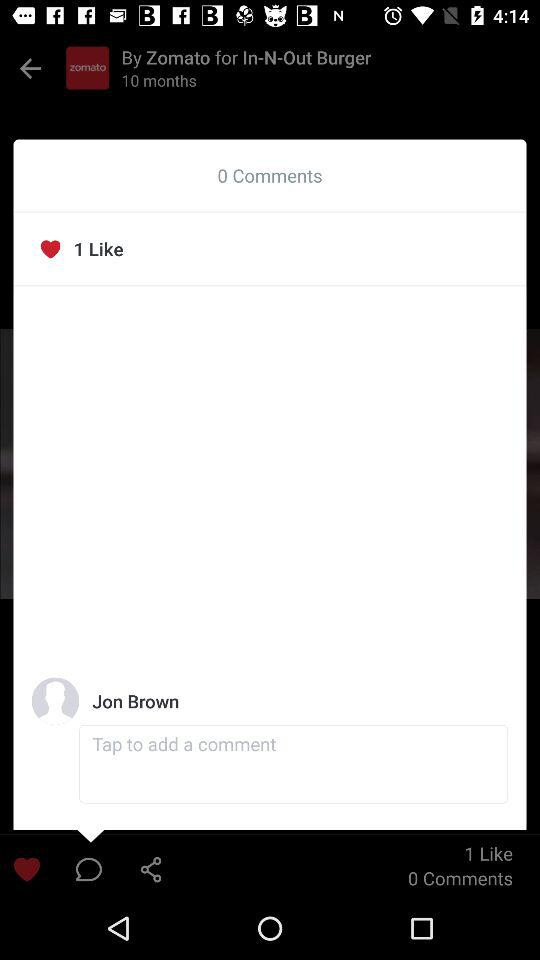How many comments are there on the post?
Answer the question using a single word or phrase. 0 